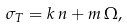<formula> <loc_0><loc_0><loc_500><loc_500>\sigma _ { T } = k \, n + m \, \Omega ,</formula> 